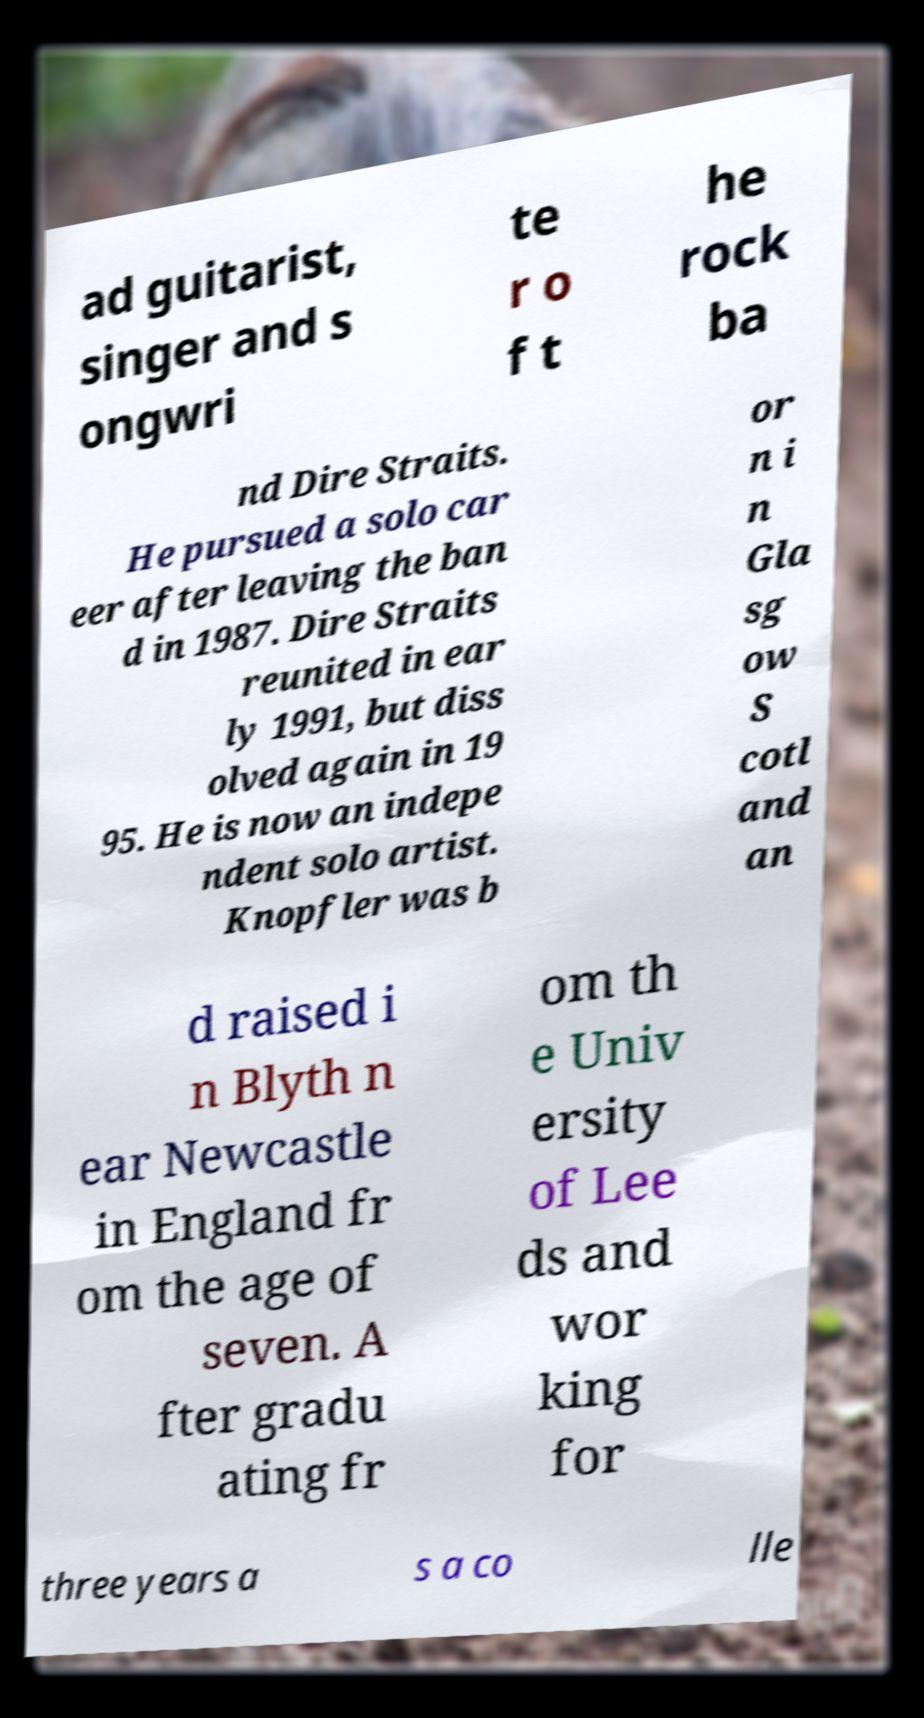Could you assist in decoding the text presented in this image and type it out clearly? ad guitarist, singer and s ongwri te r o f t he rock ba nd Dire Straits. He pursued a solo car eer after leaving the ban d in 1987. Dire Straits reunited in ear ly 1991, but diss olved again in 19 95. He is now an indepe ndent solo artist. Knopfler was b or n i n Gla sg ow S cotl and an d raised i n Blyth n ear Newcastle in England fr om the age of seven. A fter gradu ating fr om th e Univ ersity of Lee ds and wor king for three years a s a co lle 